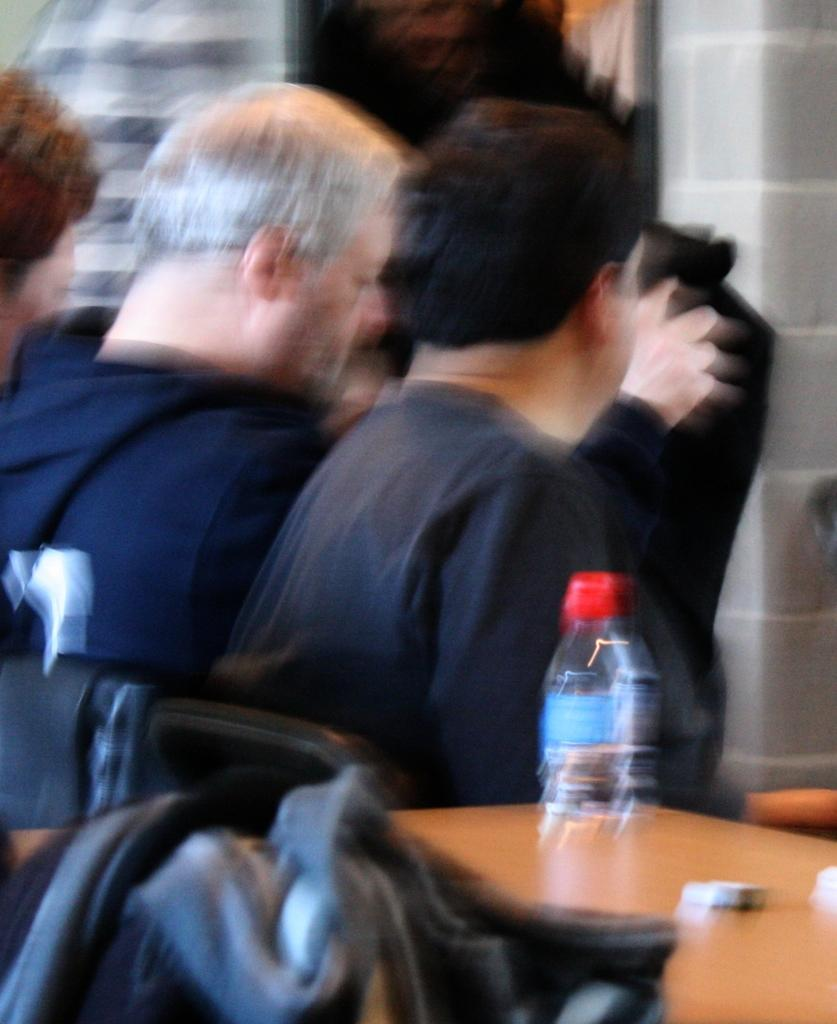What are the people in the image doing? There are persons sitting on chairs in the image. What type of material is visible in the image? There is cloth visible in the image. What is on the table in the image? There is a bottle on the table in the image, and there are objects on the table as well. What can be seen in the background of the image? There is a wall in the background of the image. What type of shade does the grandmother use to protect herself from the sun in the image? There is no grandmother or shade present in the image. What type of scale is used to weigh the objects on the table in the image? There is no scale present in the image; only a bottle and other objects are visible on the table. 